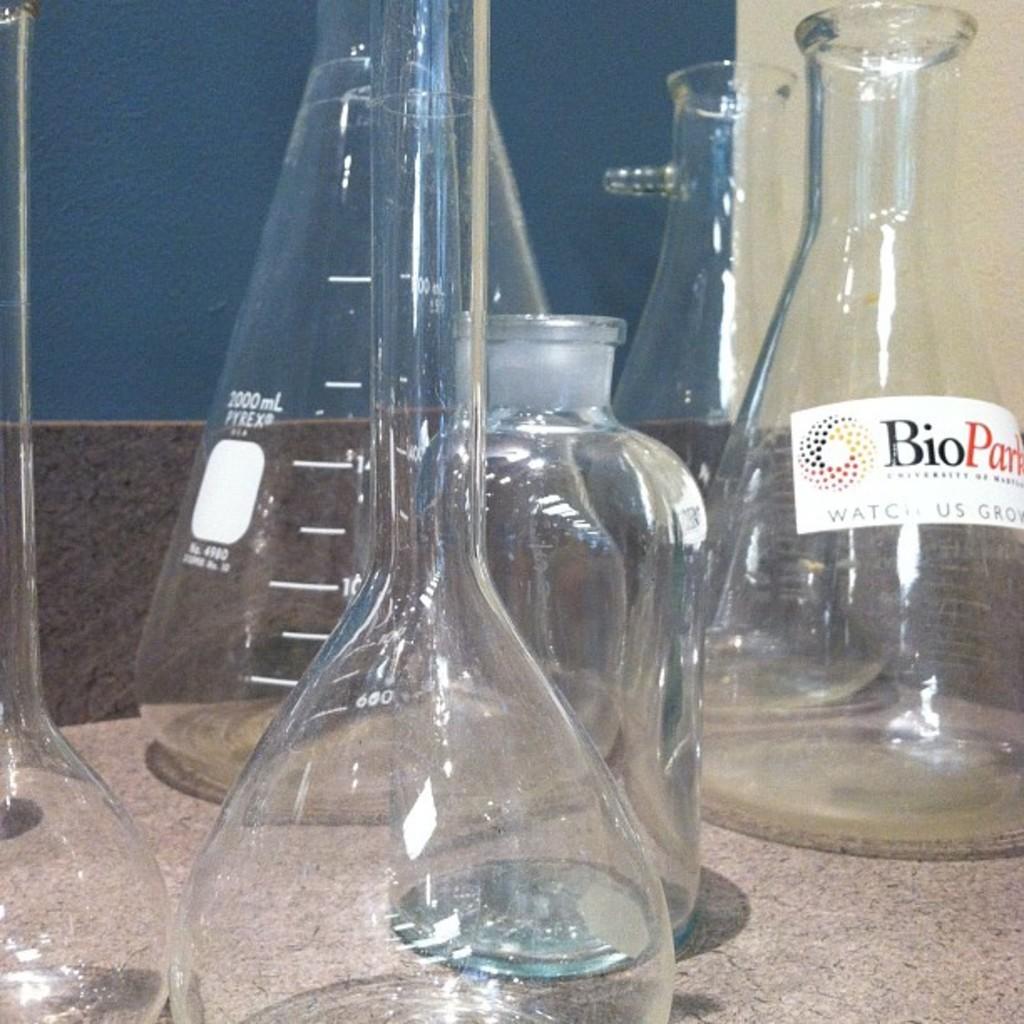How many jars can you see?
Keep it short and to the point. Answering does not require reading text in the image. What prefix can we see on the bottle on the left?
Give a very brief answer. Ml. 